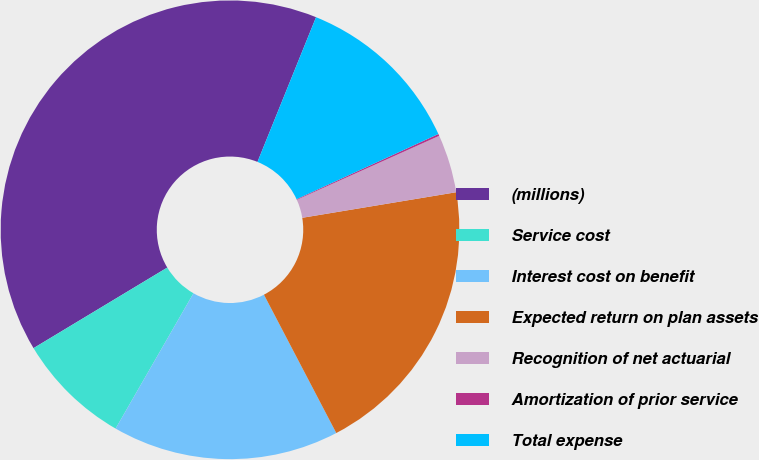<chart> <loc_0><loc_0><loc_500><loc_500><pie_chart><fcel>(millions)<fcel>Service cost<fcel>Interest cost on benefit<fcel>Expected return on plan assets<fcel>Recognition of net actuarial<fcel>Amortization of prior service<fcel>Total expense<nl><fcel>39.75%<fcel>8.06%<fcel>15.98%<fcel>19.95%<fcel>4.1%<fcel>0.14%<fcel>12.02%<nl></chart> 